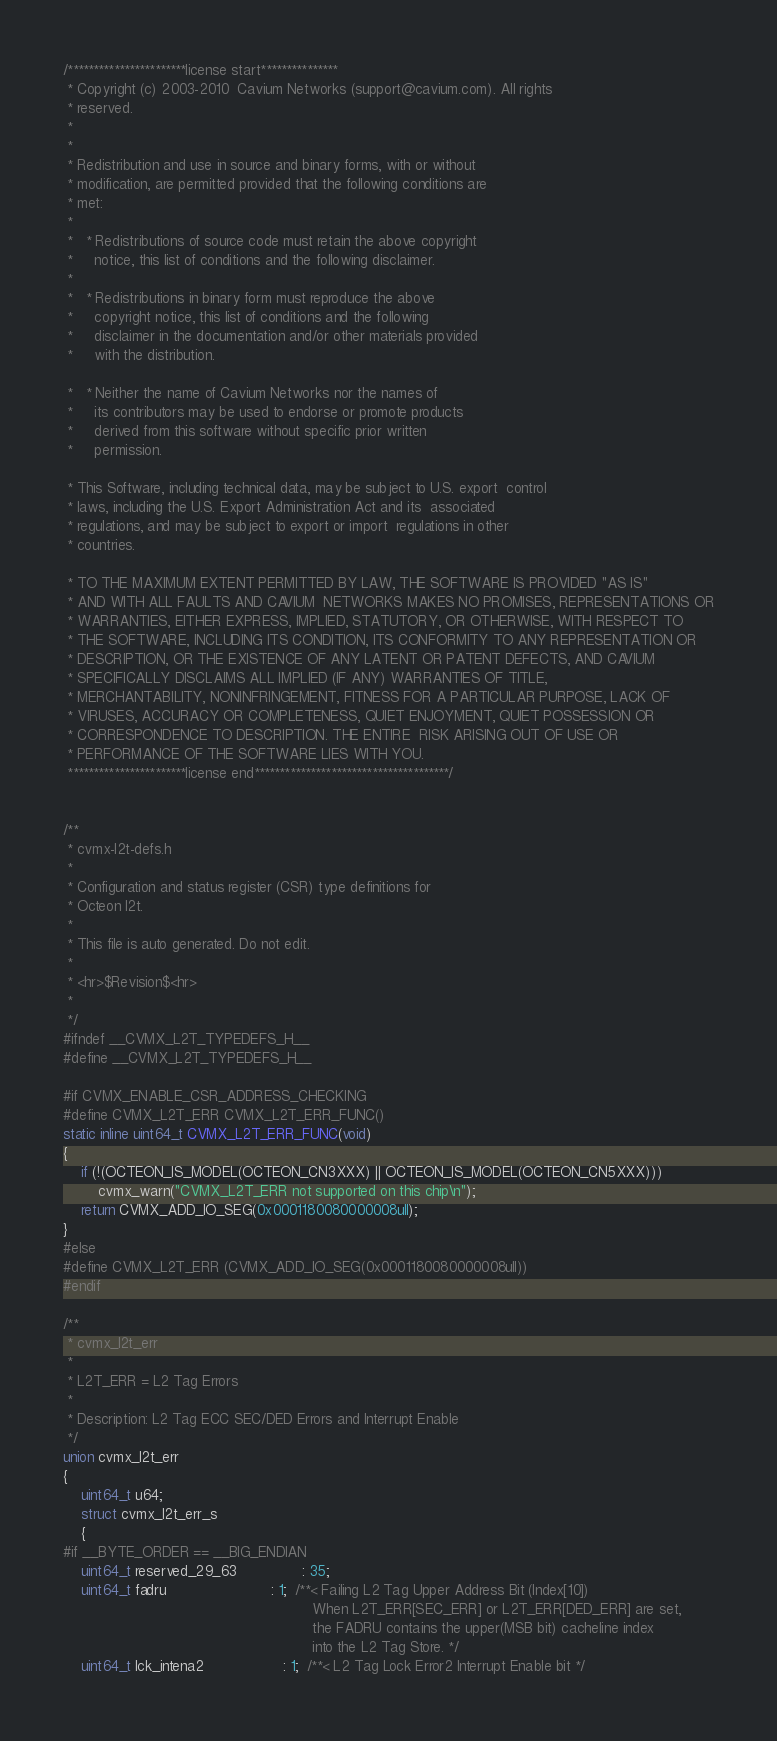<code> <loc_0><loc_0><loc_500><loc_500><_C_>/***********************license start***************
 * Copyright (c) 2003-2010  Cavium Networks (support@cavium.com). All rights
 * reserved.
 *
 *
 * Redistribution and use in source and binary forms, with or without
 * modification, are permitted provided that the following conditions are
 * met:
 *
 *   * Redistributions of source code must retain the above copyright
 *     notice, this list of conditions and the following disclaimer.
 *
 *   * Redistributions in binary form must reproduce the above
 *     copyright notice, this list of conditions and the following
 *     disclaimer in the documentation and/or other materials provided
 *     with the distribution.

 *   * Neither the name of Cavium Networks nor the names of
 *     its contributors may be used to endorse or promote products
 *     derived from this software without specific prior written
 *     permission.

 * This Software, including technical data, may be subject to U.S. export  control
 * laws, including the U.S. Export Administration Act and its  associated
 * regulations, and may be subject to export or import  regulations in other
 * countries.

 * TO THE MAXIMUM EXTENT PERMITTED BY LAW, THE SOFTWARE IS PROVIDED "AS IS"
 * AND WITH ALL FAULTS AND CAVIUM  NETWORKS MAKES NO PROMISES, REPRESENTATIONS OR
 * WARRANTIES, EITHER EXPRESS, IMPLIED, STATUTORY, OR OTHERWISE, WITH RESPECT TO
 * THE SOFTWARE, INCLUDING ITS CONDITION, ITS CONFORMITY TO ANY REPRESENTATION OR
 * DESCRIPTION, OR THE EXISTENCE OF ANY LATENT OR PATENT DEFECTS, AND CAVIUM
 * SPECIFICALLY DISCLAIMS ALL IMPLIED (IF ANY) WARRANTIES OF TITLE,
 * MERCHANTABILITY, NONINFRINGEMENT, FITNESS FOR A PARTICULAR PURPOSE, LACK OF
 * VIRUSES, ACCURACY OR COMPLETENESS, QUIET ENJOYMENT, QUIET POSSESSION OR
 * CORRESPONDENCE TO DESCRIPTION. THE ENTIRE  RISK ARISING OUT OF USE OR
 * PERFORMANCE OF THE SOFTWARE LIES WITH YOU.
 ***********************license end**************************************/


/**
 * cvmx-l2t-defs.h
 *
 * Configuration and status register (CSR) type definitions for
 * Octeon l2t.
 *
 * This file is auto generated. Do not edit.
 *
 * <hr>$Revision$<hr>
 *
 */
#ifndef __CVMX_L2T_TYPEDEFS_H__
#define __CVMX_L2T_TYPEDEFS_H__

#if CVMX_ENABLE_CSR_ADDRESS_CHECKING
#define CVMX_L2T_ERR CVMX_L2T_ERR_FUNC()
static inline uint64_t CVMX_L2T_ERR_FUNC(void)
{
	if (!(OCTEON_IS_MODEL(OCTEON_CN3XXX) || OCTEON_IS_MODEL(OCTEON_CN5XXX)))
		cvmx_warn("CVMX_L2T_ERR not supported on this chip\n");
	return CVMX_ADD_IO_SEG(0x0001180080000008ull);
}
#else
#define CVMX_L2T_ERR (CVMX_ADD_IO_SEG(0x0001180080000008ull))
#endif

/**
 * cvmx_l2t_err
 *
 * L2T_ERR = L2 Tag Errors
 *
 * Description: L2 Tag ECC SEC/DED Errors and Interrupt Enable
 */
union cvmx_l2t_err
{
	uint64_t u64;
	struct cvmx_l2t_err_s
	{
#if __BYTE_ORDER == __BIG_ENDIAN
	uint64_t reserved_29_63               : 35;
	uint64_t fadru                        : 1;  /**< Failing L2 Tag Upper Address Bit (Index[10])
                                                         When L2T_ERR[SEC_ERR] or L2T_ERR[DED_ERR] are set,
                                                         the FADRU contains the upper(MSB bit) cacheline index
                                                         into the L2 Tag Store. */
	uint64_t lck_intena2                  : 1;  /**< L2 Tag Lock Error2 Interrupt Enable bit */</code> 